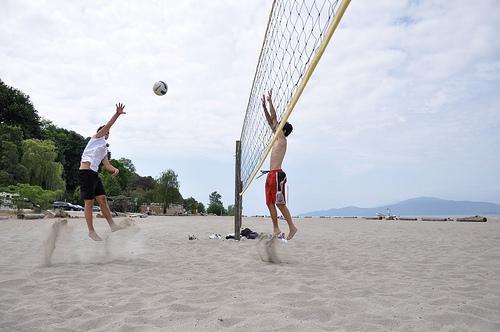How many sentient beings are dogs in this image?
Give a very brief answer. 0. 